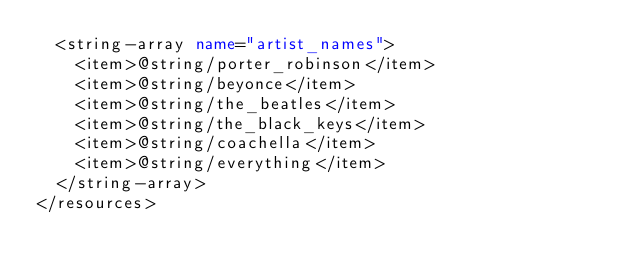Convert code to text. <code><loc_0><loc_0><loc_500><loc_500><_XML_>  <string-array name="artist_names">
    <item>@string/porter_robinson</item>
    <item>@string/beyonce</item>
    <item>@string/the_beatles</item>
    <item>@string/the_black_keys</item>
    <item>@string/coachella</item>
    <item>@string/everything</item>
  </string-array>
</resources></code> 